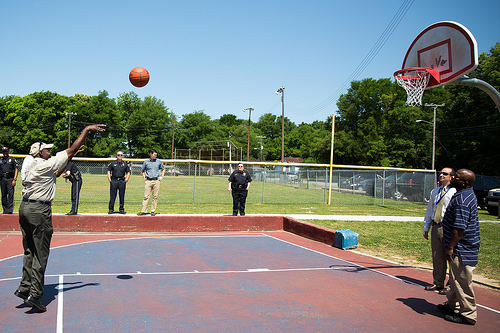<image>
Can you confirm if the sky is behind the ball? Yes. From this viewpoint, the sky is positioned behind the ball, with the ball partially or fully occluding the sky. Where is the man in relation to the officer? Is it behind the officer? No. The man is not behind the officer. From this viewpoint, the man appears to be positioned elsewhere in the scene. 